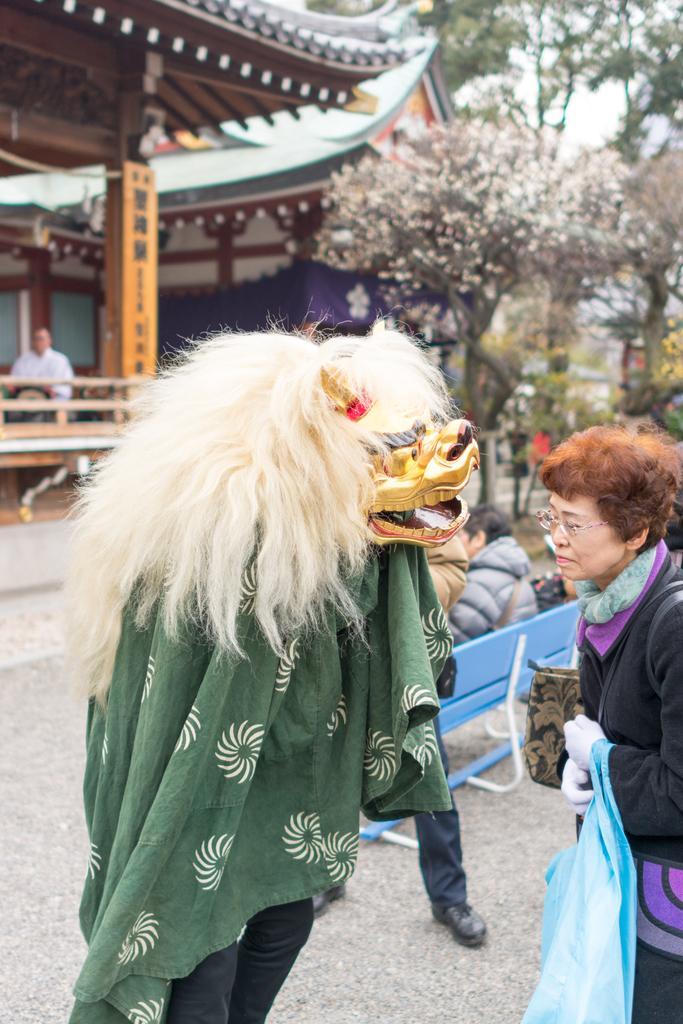In one or two sentences, can you explain what this image depicts? In the foreground of the image there is a person wearing a costume. To the right side of the image there is a lady holding a bag. In the background of the image there are trees, house, benches. At the bottom of the image there is road. 